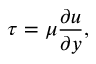Convert formula to latex. <formula><loc_0><loc_0><loc_500><loc_500>\tau = \mu { \frac { \partial u } { \partial y } } ,</formula> 